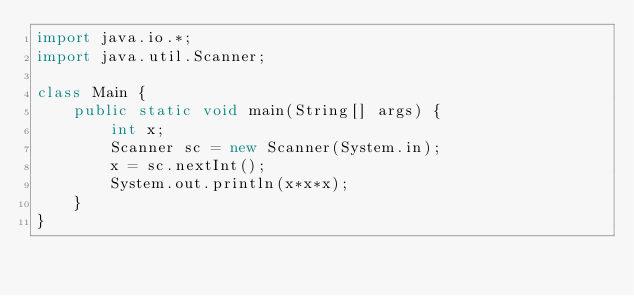Convert code to text. <code><loc_0><loc_0><loc_500><loc_500><_Java_>import java.io.*;
import java.util.Scanner;

class Main {
    public static void main(String[] args) {
        int x;
        Scanner sc = new Scanner(System.in);
        x = sc.nextInt();
        System.out.println(x*x*x);
    }
}</code> 